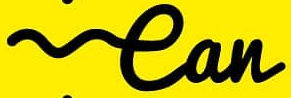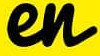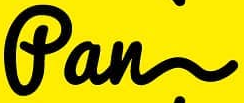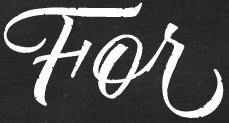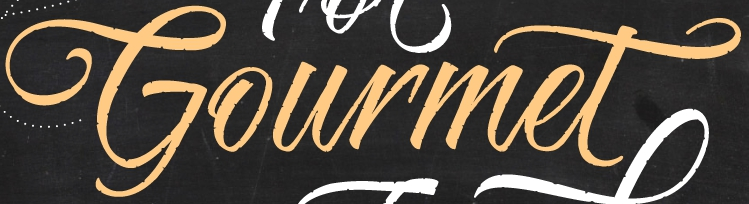Read the text content from these images in order, separated by a semicolon. ean; en; fan; For; Gourmet 